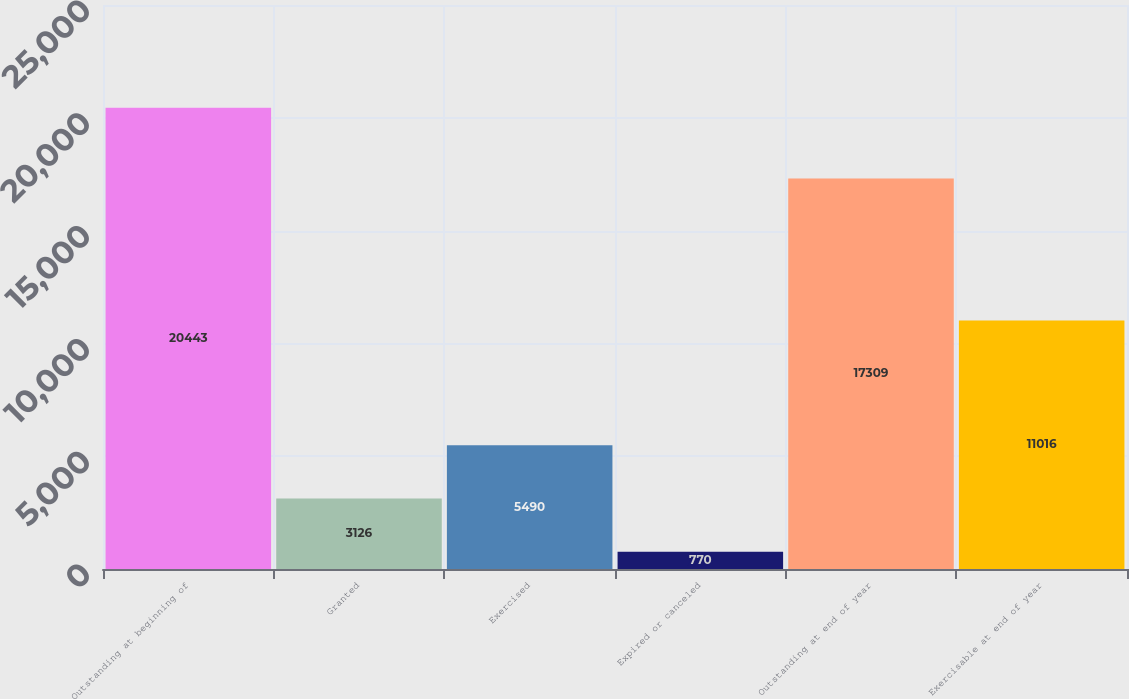<chart> <loc_0><loc_0><loc_500><loc_500><bar_chart><fcel>Outstanding at beginning of<fcel>Granted<fcel>Exercised<fcel>Expired or canceled<fcel>Outstanding at end of year<fcel>Exercisable at end of year<nl><fcel>20443<fcel>3126<fcel>5490<fcel>770<fcel>17309<fcel>11016<nl></chart> 